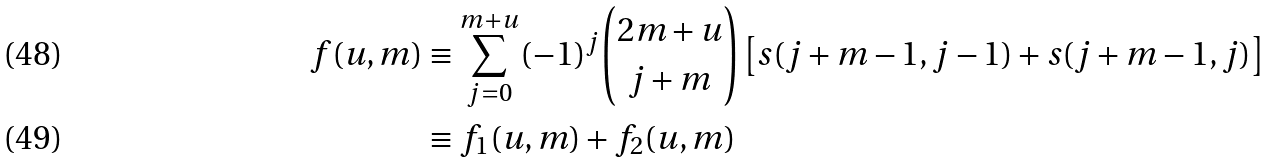Convert formula to latex. <formula><loc_0><loc_0><loc_500><loc_500>f ( u , m ) & \equiv \sum _ { j = 0 } ^ { m + u } ( - 1 ) ^ { j } { \binom { 2 m + u } { j + m } } \left [ s ( j + m - 1 , j - 1 ) + s ( j + m - 1 , j ) \right ] \\ & \equiv f _ { 1 } ( u , m ) + f _ { 2 } ( u , m )</formula> 